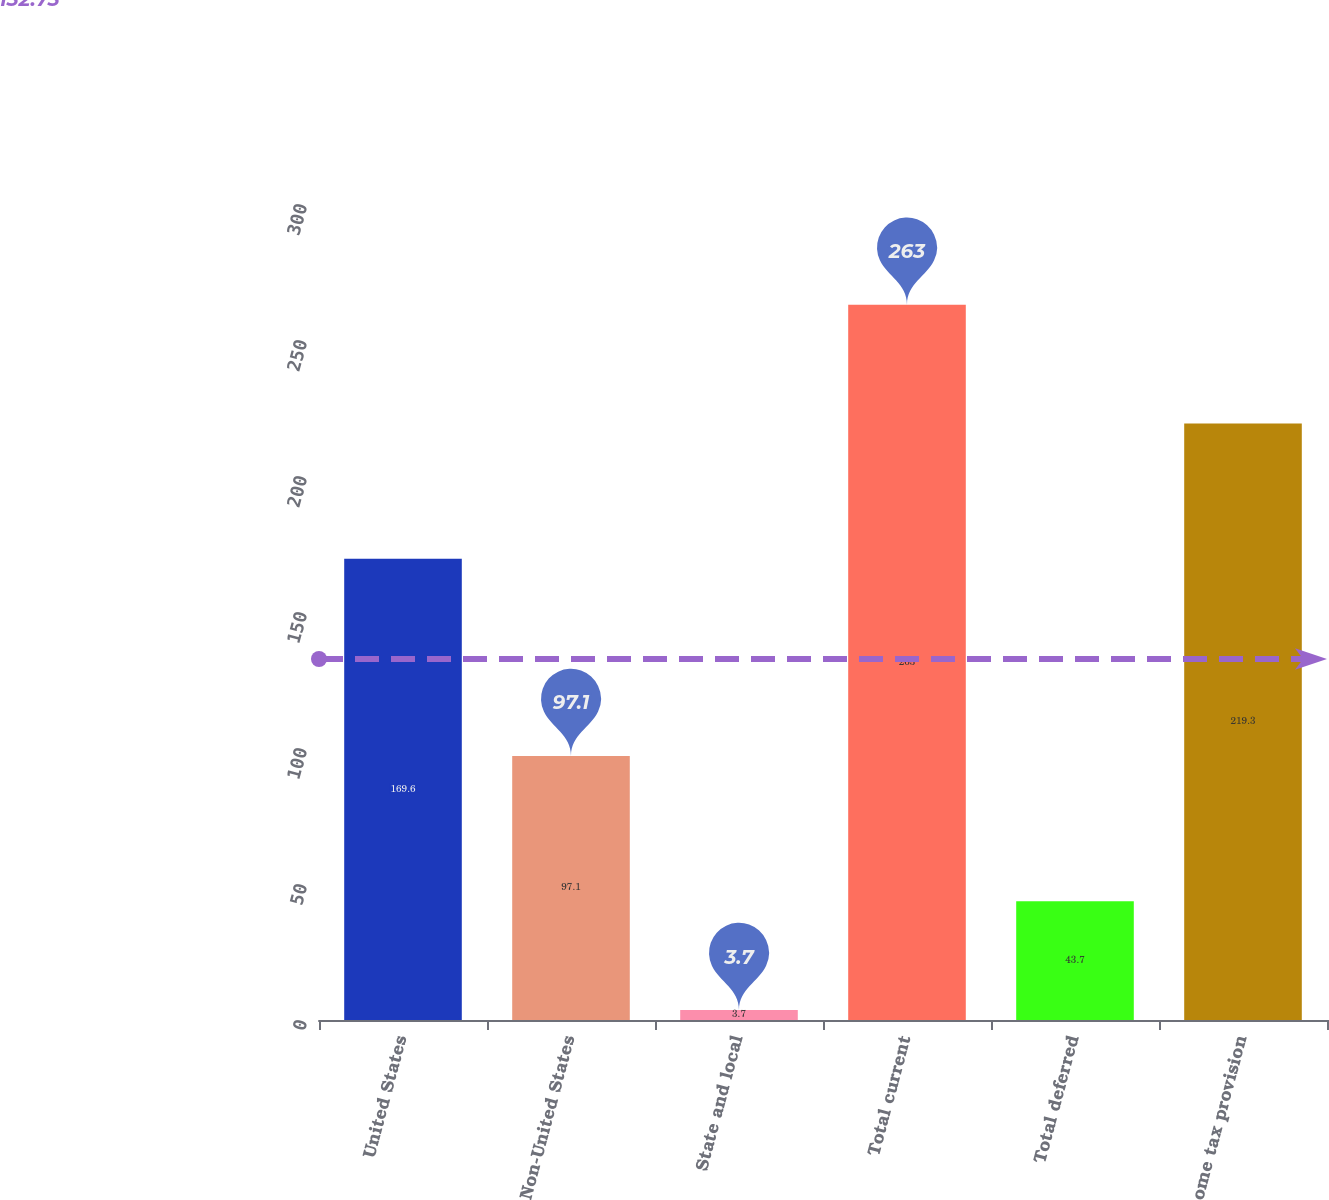Convert chart. <chart><loc_0><loc_0><loc_500><loc_500><bar_chart><fcel>United States<fcel>Non-United States<fcel>State and local<fcel>Total current<fcel>Total deferred<fcel>Income tax provision<nl><fcel>169.6<fcel>97.1<fcel>3.7<fcel>263<fcel>43.7<fcel>219.3<nl></chart> 